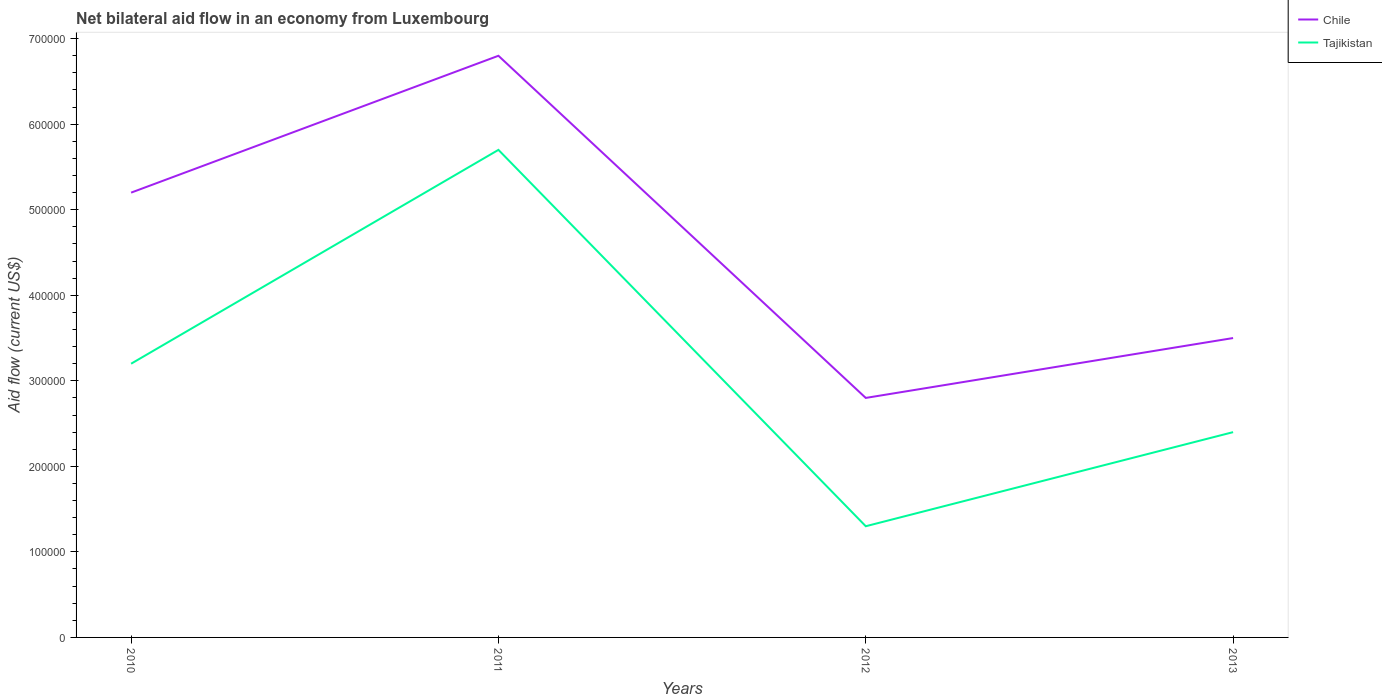Is the number of lines equal to the number of legend labels?
Give a very brief answer. Yes. Across all years, what is the maximum net bilateral aid flow in Chile?
Give a very brief answer. 2.80e+05. What is the total net bilateral aid flow in Chile in the graph?
Keep it short and to the point. -7.00e+04. What is the difference between the highest and the second highest net bilateral aid flow in Chile?
Offer a terse response. 4.00e+05. Are the values on the major ticks of Y-axis written in scientific E-notation?
Make the answer very short. No. Does the graph contain grids?
Offer a terse response. No. How many legend labels are there?
Provide a succinct answer. 2. What is the title of the graph?
Make the answer very short. Net bilateral aid flow in an economy from Luxembourg. Does "Bosnia and Herzegovina" appear as one of the legend labels in the graph?
Ensure brevity in your answer.  No. What is the Aid flow (current US$) in Chile in 2010?
Your response must be concise. 5.20e+05. What is the Aid flow (current US$) in Tajikistan in 2010?
Your response must be concise. 3.20e+05. What is the Aid flow (current US$) in Chile in 2011?
Offer a very short reply. 6.80e+05. What is the Aid flow (current US$) of Tajikistan in 2011?
Your answer should be very brief. 5.70e+05. What is the Aid flow (current US$) of Tajikistan in 2012?
Your answer should be compact. 1.30e+05. What is the Aid flow (current US$) in Chile in 2013?
Your answer should be very brief. 3.50e+05. Across all years, what is the maximum Aid flow (current US$) in Chile?
Ensure brevity in your answer.  6.80e+05. Across all years, what is the maximum Aid flow (current US$) of Tajikistan?
Keep it short and to the point. 5.70e+05. What is the total Aid flow (current US$) of Chile in the graph?
Give a very brief answer. 1.83e+06. What is the total Aid flow (current US$) of Tajikistan in the graph?
Your response must be concise. 1.26e+06. What is the difference between the Aid flow (current US$) in Tajikistan in 2010 and that in 2012?
Provide a short and direct response. 1.90e+05. What is the difference between the Aid flow (current US$) in Chile in 2010 and that in 2013?
Keep it short and to the point. 1.70e+05. What is the difference between the Aid flow (current US$) in Tajikistan in 2011 and that in 2012?
Make the answer very short. 4.40e+05. What is the difference between the Aid flow (current US$) in Chile in 2010 and the Aid flow (current US$) in Tajikistan in 2011?
Offer a very short reply. -5.00e+04. What is the difference between the Aid flow (current US$) of Chile in 2010 and the Aid flow (current US$) of Tajikistan in 2012?
Your answer should be compact. 3.90e+05. What is the difference between the Aid flow (current US$) of Chile in 2011 and the Aid flow (current US$) of Tajikistan in 2012?
Your answer should be very brief. 5.50e+05. What is the difference between the Aid flow (current US$) in Chile in 2011 and the Aid flow (current US$) in Tajikistan in 2013?
Your answer should be very brief. 4.40e+05. What is the difference between the Aid flow (current US$) in Chile in 2012 and the Aid flow (current US$) in Tajikistan in 2013?
Keep it short and to the point. 4.00e+04. What is the average Aid flow (current US$) of Chile per year?
Ensure brevity in your answer.  4.58e+05. What is the average Aid flow (current US$) of Tajikistan per year?
Your answer should be compact. 3.15e+05. In the year 2011, what is the difference between the Aid flow (current US$) of Chile and Aid flow (current US$) of Tajikistan?
Offer a terse response. 1.10e+05. In the year 2013, what is the difference between the Aid flow (current US$) of Chile and Aid flow (current US$) of Tajikistan?
Ensure brevity in your answer.  1.10e+05. What is the ratio of the Aid flow (current US$) in Chile in 2010 to that in 2011?
Keep it short and to the point. 0.76. What is the ratio of the Aid flow (current US$) of Tajikistan in 2010 to that in 2011?
Ensure brevity in your answer.  0.56. What is the ratio of the Aid flow (current US$) of Chile in 2010 to that in 2012?
Offer a terse response. 1.86. What is the ratio of the Aid flow (current US$) of Tajikistan in 2010 to that in 2012?
Your answer should be compact. 2.46. What is the ratio of the Aid flow (current US$) of Chile in 2010 to that in 2013?
Ensure brevity in your answer.  1.49. What is the ratio of the Aid flow (current US$) of Tajikistan in 2010 to that in 2013?
Offer a very short reply. 1.33. What is the ratio of the Aid flow (current US$) in Chile in 2011 to that in 2012?
Provide a short and direct response. 2.43. What is the ratio of the Aid flow (current US$) in Tajikistan in 2011 to that in 2012?
Provide a short and direct response. 4.38. What is the ratio of the Aid flow (current US$) of Chile in 2011 to that in 2013?
Provide a succinct answer. 1.94. What is the ratio of the Aid flow (current US$) in Tajikistan in 2011 to that in 2013?
Give a very brief answer. 2.38. What is the ratio of the Aid flow (current US$) of Tajikistan in 2012 to that in 2013?
Offer a very short reply. 0.54. What is the difference between the highest and the second highest Aid flow (current US$) in Chile?
Your response must be concise. 1.60e+05. What is the difference between the highest and the second highest Aid flow (current US$) in Tajikistan?
Your answer should be very brief. 2.50e+05. What is the difference between the highest and the lowest Aid flow (current US$) in Tajikistan?
Make the answer very short. 4.40e+05. 